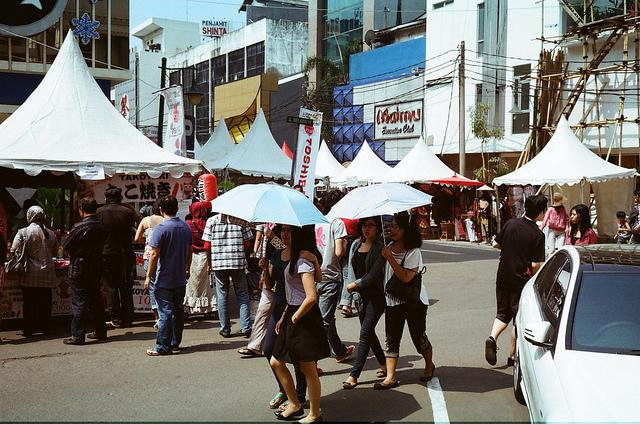Why are the people carrying umbrellas? Please explain your reasoning. blocking sun. The sun is bright. 